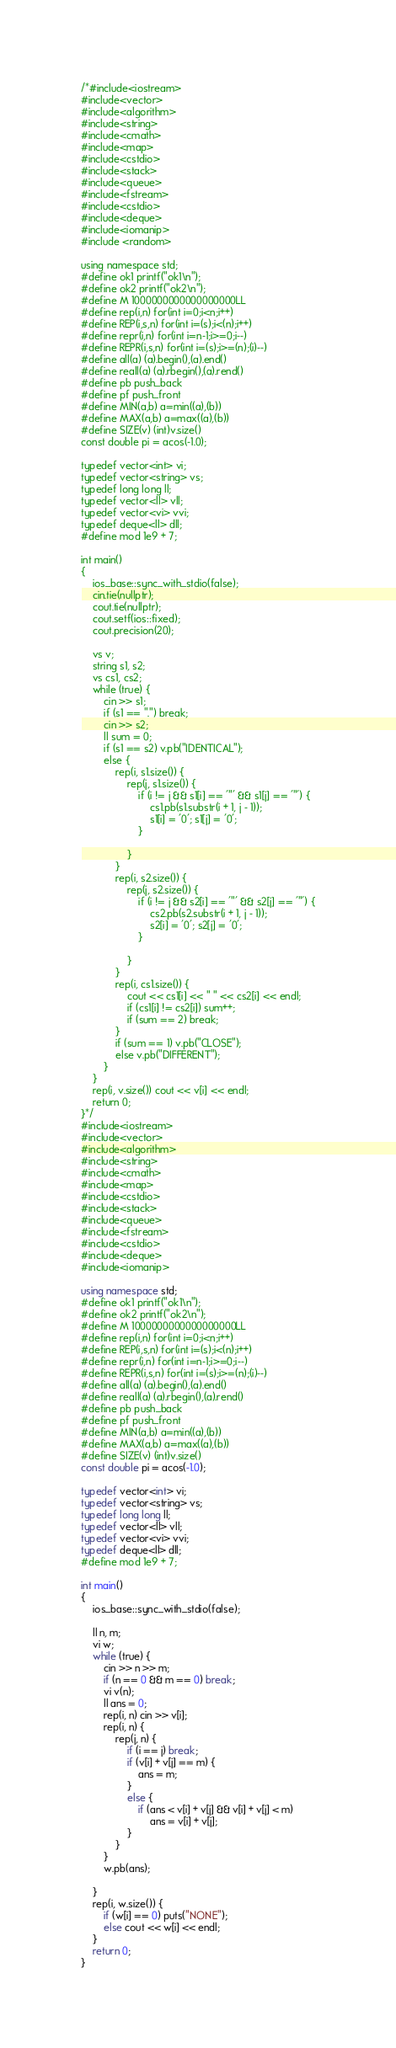<code> <loc_0><loc_0><loc_500><loc_500><_C++_>/*#include<iostream>
#include<vector>
#include<algorithm>
#include<string>
#include<cmath>
#include<map>
#include<cstdio>
#include<stack>
#include<queue>
#include<fstream>
#include<cstdio>
#include<deque>
#include<iomanip>
#include <random>

using namespace std;
#define ok1 printf("ok1\n");
#define ok2 printf("ok2\n");
#define M 1000000000000000000LL
#define rep(i,n) for(int i=0;i<n;i++)
#define REP(i,s,n) for(int i=(s);i<(n);i++)
#define repr(i,n) for(int i=n-1;i>=0;i--)
#define REPR(i,s,n) for(int i=(s);i>=(n);(i)--)
#define all(a) (a).begin(),(a).end()
#define reall(a) (a).rbegin(),(a).rend()
#define pb push_back
#define pf push_front
#define MIN(a,b) a=min((a),(b))
#define MAX(a,b) a=max((a),(b))
#define SIZE(v) (int)v.size()
const double pi = acos(-1.0);

typedef vector<int> vi;
typedef vector<string> vs;
typedef long long ll;
typedef vector<ll> vll;
typedef vector<vi> vvi;
typedef deque<ll> dll;
#define mod 1e9 + 7;

int main()
{
	ios_base::sync_with_stdio(false);
	cin.tie(nullptr);
	cout.tie(nullptr);
	cout.setf(ios::fixed);
	cout.precision(20);

	vs v;
	string s1, s2;
	vs cs1, cs2;
	while (true) {
		cin >> s1;
		if (s1 == ".") break;
		cin >> s2;
		ll sum = 0;
		if (s1 == s2) v.pb("IDENTICAL");
		else {
			rep(i, s1.size()) {
				rep(j, s1.size()) {
					if (i != j && s1[i] == '"' && s1[j] == '"') {
						cs1.pb(s1.substr(i + 1, j - 1));
						s1[i] = '0'; s1[j] = '0';
					}

				}
			}
			rep(i, s2.size()) {
				rep(j, s2.size()) {
					if (i != j && s2[i] == '"' && s2[j] == '"') {
						cs2.pb(s2.substr(i + 1, j - 1));
						s2[i] = '0'; s2[j] = '0';
					}

				}
			}
			rep(i, cs1.size()) {
				cout << cs1[i] << " " << cs2[i] << endl;
				if (cs1[i] != cs2[i]) sum++;
				if (sum == 2) break;
			}
			if (sum == 1) v.pb("CLOSE");
			else v.pb("DIFFERENT");
		}
	}
	rep(i, v.size()) cout << v[i] << endl;
	return 0;
}*/
#include<iostream>
#include<vector>
#include<algorithm>
#include<string>
#include<cmath>
#include<map>
#include<cstdio>
#include<stack>
#include<queue>
#include<fstream>
#include<cstdio>
#include<deque>
#include<iomanip>

using namespace std;
#define ok1 printf("ok1\n");
#define ok2 printf("ok2\n");
#define M 1000000000000000000LL
#define rep(i,n) for(int i=0;i<n;i++)
#define REP(i,s,n) for(int i=(s);i<(n);i++)
#define repr(i,n) for(int i=n-1;i>=0;i--)
#define REPR(i,s,n) for(int i=(s);i>=(n);(i)--)
#define all(a) (a).begin(),(a).end()
#define reall(a) (a).rbegin(),(a).rend()
#define pb push_back
#define pf push_front
#define MIN(a,b) a=min((a),(b))
#define MAX(a,b) a=max((a),(b))
#define SIZE(v) (int)v.size()
const double pi = acos(-1.0);

typedef vector<int> vi;
typedef vector<string> vs;
typedef long long ll;
typedef vector<ll> vll;
typedef vector<vi> vvi;
typedef deque<ll> dll;
#define mod 1e9 + 7;

int main()
{
	ios_base::sync_with_stdio(false);

	ll n, m;
	vi w;
	while (true) {
		cin >> n >> m;
		if (n == 0 && m == 0) break;
		vi v(n);
		ll ans = 0;
		rep(i, n) cin >> v[i];
		rep(i, n) {
			rep(j, n) {
				if (i == j) break;
				if (v[i] + v[j] == m) {
					ans = m;
				}
				else {
					if (ans < v[i] + v[j] && v[i] + v[j] < m)
						ans = v[i] + v[j];
				}
			}
		}
		w.pb(ans);
		
	}
	rep(i, w.size()) {
		if (w[i] == 0) puts("NONE");
		else cout << w[i] << endl;
	}
	return 0;
}

</code> 